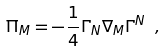Convert formula to latex. <formula><loc_0><loc_0><loc_500><loc_500>\Pi _ { M } = - \frac { 1 } { 4 } \Gamma _ { N } \nabla _ { M } \Gamma ^ { N } \ ,</formula> 